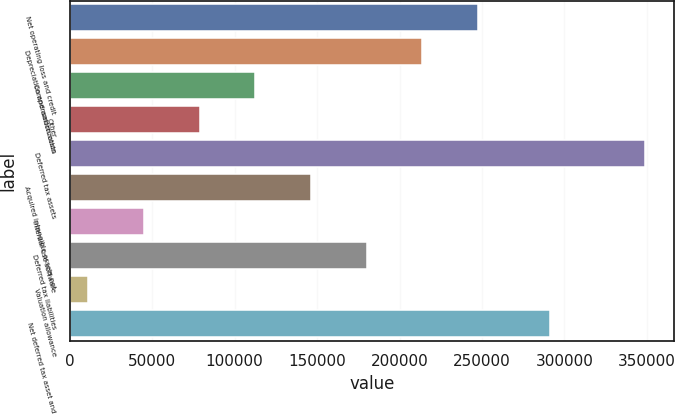<chart> <loc_0><loc_0><loc_500><loc_500><bar_chart><fcel>Net operating loss and credit<fcel>Depreciation and amortization<fcel>Compensation costs<fcel>Other<fcel>Deferred tax assets<fcel>Acquired intangible assets not<fcel>Internal-use software<fcel>Deferred tax liabilities<fcel>Valuation allowance<fcel>Net deferred tax asset and<nl><fcel>247678<fcel>213890<fcel>112524<fcel>78735.2<fcel>349044<fcel>146312<fcel>44946.6<fcel>180101<fcel>11158<fcel>291366<nl></chart> 